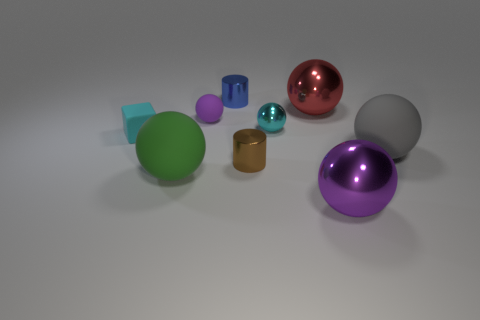What size is the blue cylinder to the left of the large matte thing to the right of the big purple ball?
Give a very brief answer. Small. Are there the same number of balls that are left of the purple metal ball and large green balls behind the purple matte thing?
Ensure brevity in your answer.  No. There is a tiny shiny cylinder behind the purple matte object; is there a rubber object in front of it?
Your answer should be compact. Yes. There is a cyan matte block behind the big matte ball left of the small brown shiny cylinder; what number of balls are in front of it?
Your answer should be very brief. 3. Is the number of large red spheres less than the number of cylinders?
Offer a very short reply. Yes. There is a purple thing behind the green matte sphere; does it have the same shape as the large metal thing that is behind the brown cylinder?
Offer a terse response. Yes. What color is the tiny rubber cube?
Provide a short and direct response. Cyan. What number of metallic objects are either small brown things or cyan spheres?
Your answer should be very brief. 2. What color is the other object that is the same shape as the blue metallic object?
Your answer should be compact. Brown. Are there any large shiny balls?
Your answer should be very brief. Yes. 